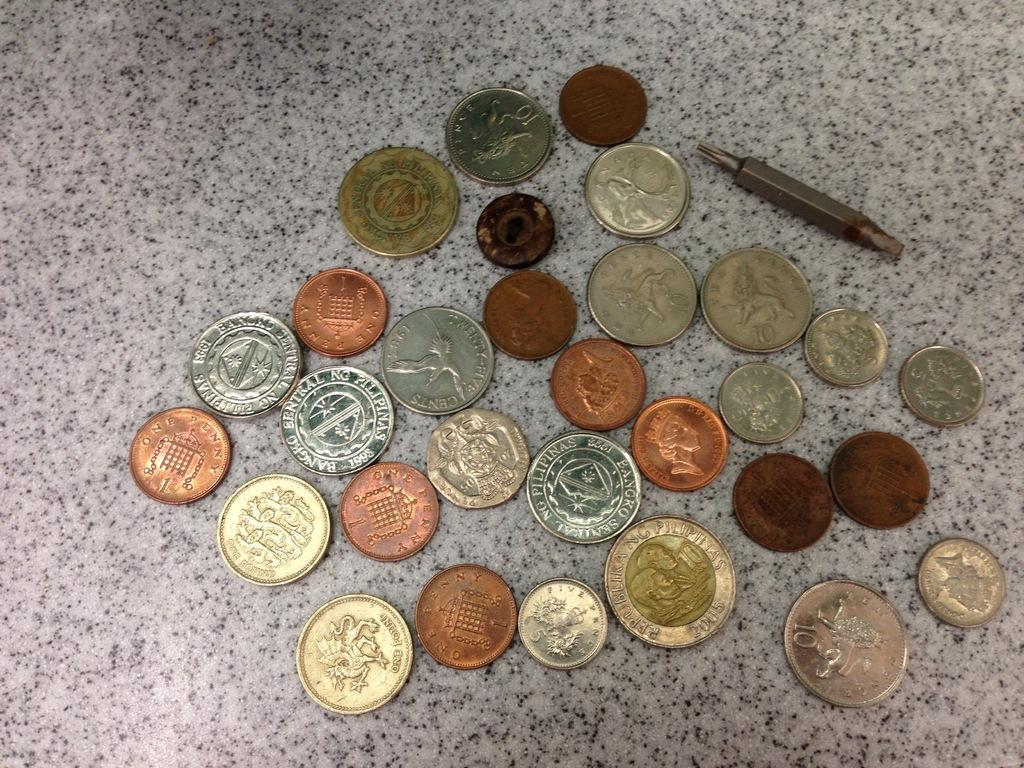Provide a one-sentence caption for the provided image. A random collection of coins include some from the Philippines. 